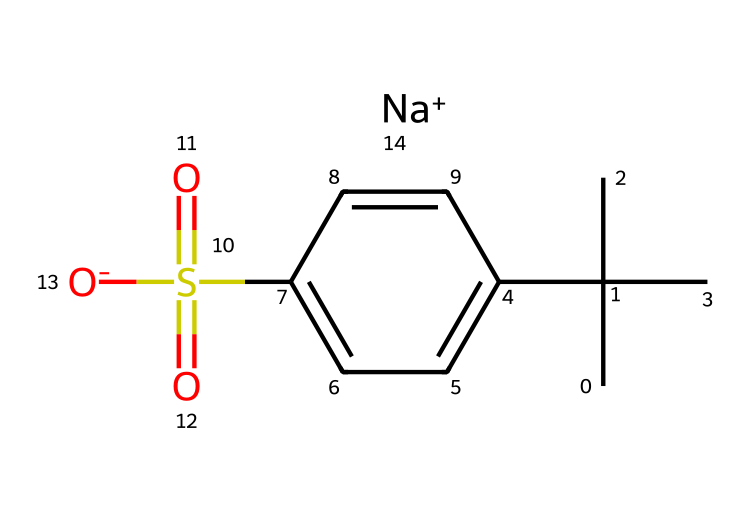What is the total number of carbon atoms in this molecule? The SMILES representation shows the presence of multiple 'C' symbols, each representing a carbon atom. Counting them gives a total of 10 carbon atoms.
Answer: 10 How many oxygen atoms are present in the chemical structure? The 'O' symbol appears twice in the structure, indicating the presence of two oxygen atoms in the molecule.
Answer: 2 What type of ion is the sodium part in this chemical? The 'Na+' in the SMILES notation indicates that it is a positively charged sodium ion, commonly associated with ionic bonding in surfactants.
Answer: sodium Which functional group is indicated by the 'S(=O)(=O)' part of the chemical? This notation indicates a sulfonate group, as sulfur is bonded to three oxygen atoms, two of which are double-bonded, which is characteristic of sulfonates.
Answer: sulfonate How does the presence of the alkyl chain affect the properties of this surfactant? The long alkyl chain contributes to hydrophobic characteristics, which aids in the surfactant's ability to interact with oils and greases, promoting emulsification and cleaning.
Answer: hydrophobic What is the role of the surfactant in marine engine degreasers? Surfactants like this one lower surface tension, allowing the mixture to spread and penetrate greases and oils, facilitating their removal from surfaces.
Answer: cleaning agent 